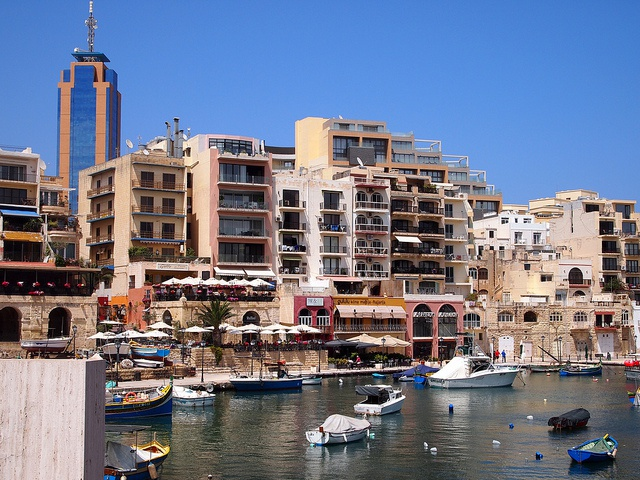Describe the objects in this image and their specific colors. I can see umbrella in gray, black, white, and maroon tones, boat in gray, white, darkgray, and black tones, boat in gray, black, white, and maroon tones, boat in gray, black, navy, and darkgray tones, and boat in gray, lightgray, darkgray, and black tones in this image. 